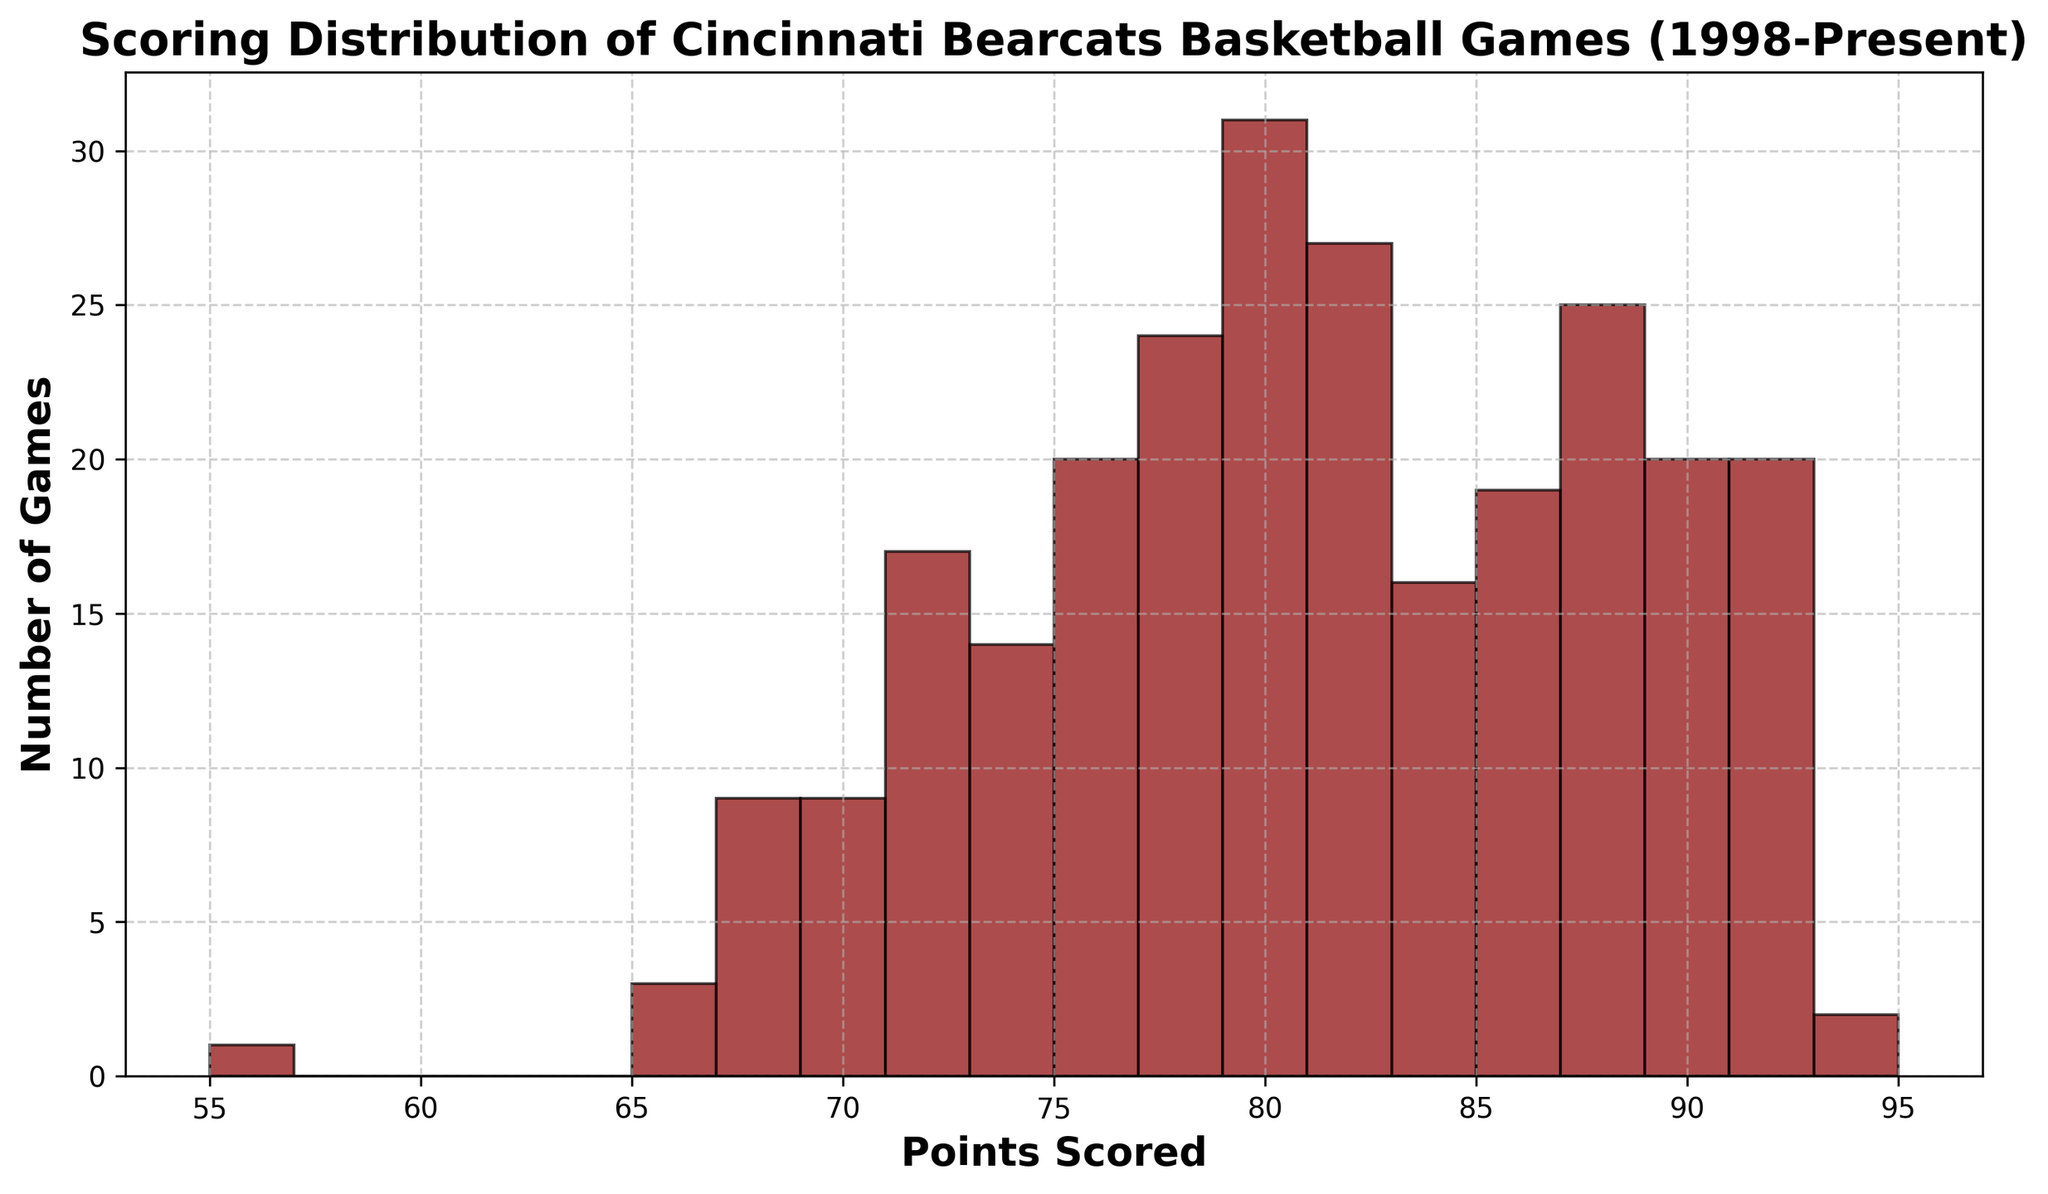What is the most common scoring range for the Cincinnati Bearcats basketball games from 1998 to present? Look at the histogram bars to identify the highest one or the range that appears to have the most games.
Answer: The range with the highest bar Which score range has the least number of games? Find the bar with the lowest height in the histogram.
Answer: The range with the lowest bar What is the approximate range of points where most of the games fall? Look for the range where majority of the bars are clustered, typically indicating the peak of the distribution.
Answer: The range around the tallest bars Between 80-90 points and 60-70 points, which range has more games? Compare the heights of the bars in the 80-90 points range versus the 60-70 points range. The higher set represents more games.
Answer: The range with taller bars What's the widest range where, on average, the Bearcats score their points? Analyze the spread of the histogram and identify the central range encompassing the majority of the data points.
Answer: The central range around the tallest bars Is there a range of points that noticeably stands out in its frequency? Identify if any histogram bar is significantly taller than the rest, implying a distinct frequency for that score range.
Answer: The range with the distinctively taller bar How does the distribution of scores in the 70s compare to the 90s? Visually compare the collective height of bars representing the score ranges in the 70s to those in the 90s.
Answer: The range with the overall taller bars Are there any point ranges where no Bearcats games have scored? Check for any score ranges in the histogram without any bars, indicating zero games in that range.
Answer: Any range with no bars What's the mode of the scoring distribution from 1998 to present? Identify the score or range that appears most frequently by locating the highest bar on the histogram.
Answer: The point range with the highest bar Between the ranges of 60-70, 70-80, and 80-90 points, which has the greatest number of games? Compare the collective heights of the bars within each of these three ranges to determine which range has the most games.
Answer: The range with the overall tallest bars 